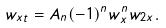<formula> <loc_0><loc_0><loc_500><loc_500>w _ { x t } = A _ { n } ( - 1 ) ^ { n } w _ { x } ^ { n } w _ { 2 x } .</formula> 